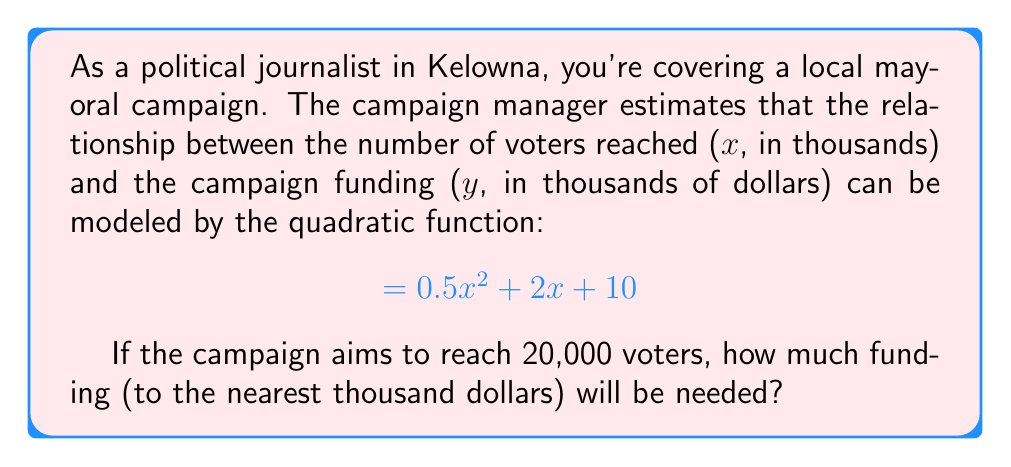Could you help me with this problem? To solve this problem, we need to use the given quadratic function and substitute the number of voters we want to reach:

1. The function is given as: $$y = 0.5x^2 + 2x + 10$$

2. We want to reach 20,000 voters, which is 20 thousand. So, we substitute $x = 20$ into the equation:

   $$y = 0.5(20)^2 + 2(20) + 10$$

3. Let's calculate step by step:
   
   $$y = 0.5(400) + 40 + 10$$
   $$y = 200 + 40 + 10$$
   $$y = 250$$

4. The result, 250, represents thousands of dollars. So the actual amount is $250,000.

5. Rounding to the nearest thousand dollars doesn't change this value.

Therefore, the campaign will need $250,000 to reach 20,000 voters according to this model.
Answer: $250,000 